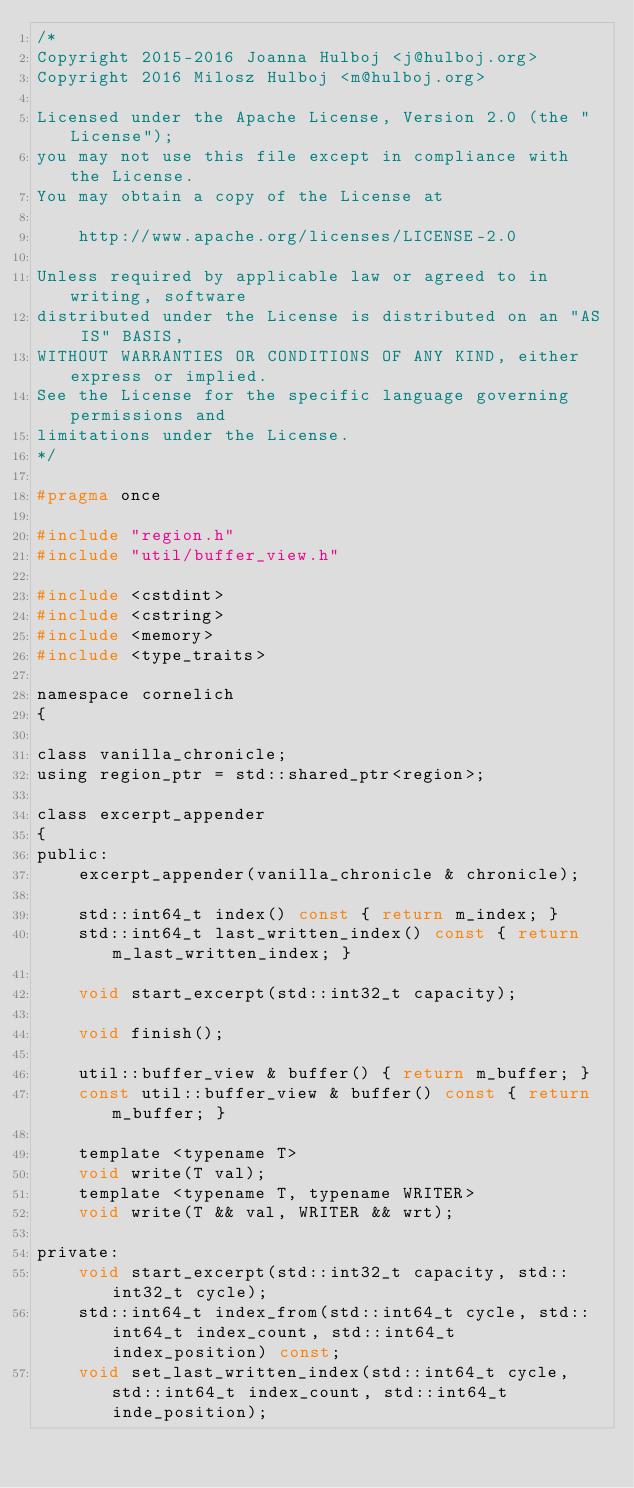Convert code to text. <code><loc_0><loc_0><loc_500><loc_500><_C_>/*
Copyright 2015-2016 Joanna Hulboj <j@hulboj.org>
Copyright 2016 Milosz Hulboj <m@hulboj.org>

Licensed under the Apache License, Version 2.0 (the "License");
you may not use this file except in compliance with the License.
You may obtain a copy of the License at

    http://www.apache.org/licenses/LICENSE-2.0

Unless required by applicable law or agreed to in writing, software
distributed under the License is distributed on an "AS IS" BASIS,
WITHOUT WARRANTIES OR CONDITIONS OF ANY KIND, either express or implied.
See the License for the specific language governing permissions and
limitations under the License.
*/

#pragma once

#include "region.h"
#include "util/buffer_view.h"

#include <cstdint>
#include <cstring>
#include <memory>
#include <type_traits>

namespace cornelich
{

class vanilla_chronicle;
using region_ptr = std::shared_ptr<region>;

class excerpt_appender
{
public:
    excerpt_appender(vanilla_chronicle & chronicle);

    std::int64_t index() const { return m_index; }
    std::int64_t last_written_index() const { return m_last_written_index; }

    void start_excerpt(std::int32_t capacity);

    void finish();

    util::buffer_view & buffer() { return m_buffer; }
    const util::buffer_view & buffer() const { return m_buffer; }

    template <typename T>
    void write(T val);
    template <typename T, typename WRITER>
    void write(T && val, WRITER && wrt);

private:
    void start_excerpt(std::int32_t capacity, std::int32_t cycle);
    std::int64_t index_from(std::int64_t cycle, std::int64_t index_count, std::int64_t index_position) const;
    void set_last_written_index(std::int64_t cycle, std::int64_t index_count, std::int64_t inde_position);
</code> 